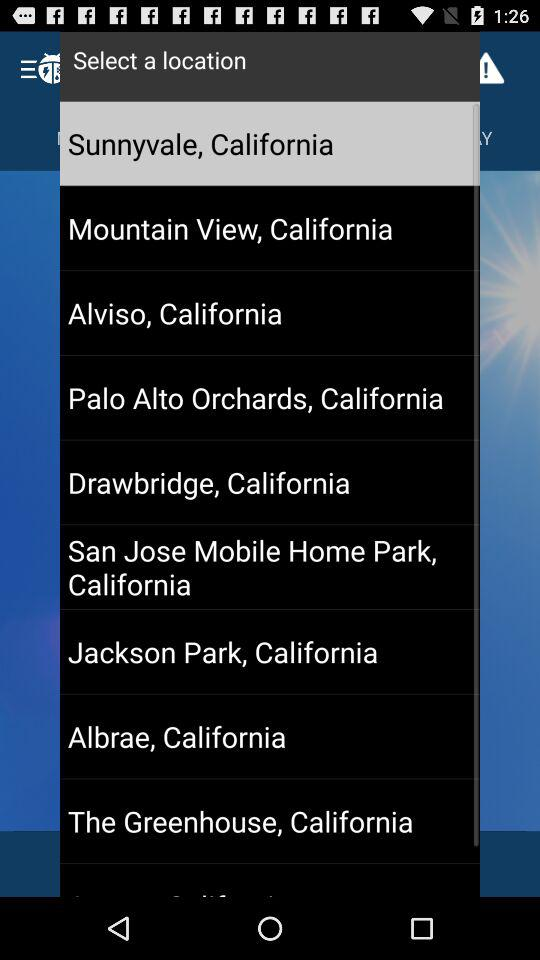What is the selected location? The selected location is Sunnyvale, California. 